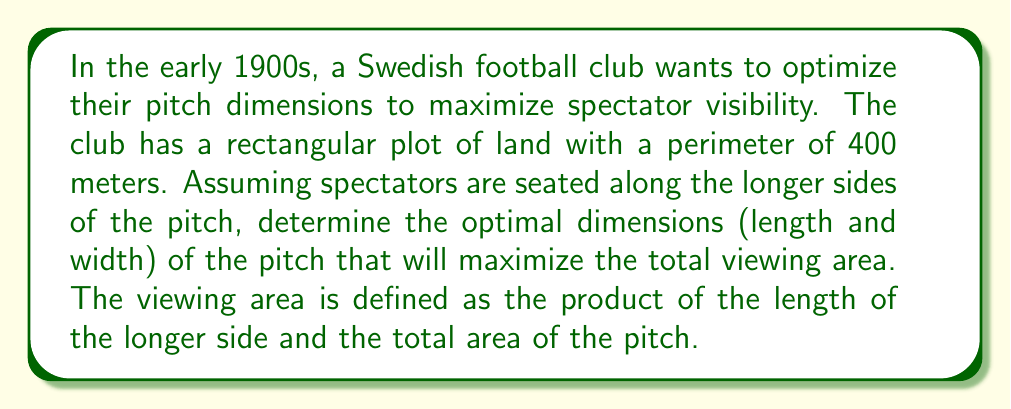Teach me how to tackle this problem. Let's approach this step-by-step:

1) Let $l$ be the length and $w$ be the width of the pitch.

2) Given that the perimeter is 400 meters, we can write:
   $$2l + 2w = 400$$
   $$l + w = 200$$

3) We can express $w$ in terms of $l$:
   $$w = 200 - l$$

4) The area of the pitch is:
   $$A = l \cdot w = l(200-l) = 200l - l^2$$

5) The viewing area (V) is defined as the product of the length and the total area:
   $$V = l \cdot A = l(200l - l^2) = 200l^2 - l^3$$

6) To find the maximum, we differentiate V with respect to l and set it to zero:
   $$\frac{dV}{dl} = 400l - 3l^2 = 0$$

7) Solving this equation:
   $$l(400 - 3l) = 0$$
   $$l = 0$$ or $$400 - 3l = 0$$
   $$l \approx 133.33$$ meters

8) The second derivative is negative at this point, confirming it's a maximum.

9) We can now calculate the width:
   $$w = 200 - 133.33 \approx 66.67$$ meters

[asy]
size(200);
draw((0,0)--(133.33,0)--(133.33,66.67)--(0,66.67)--cycle);
label("133.33 m", (66.67,0), S);
label("66.67 m", (0,33.33), W);
label("Spectators", (66.67,70), N);
label("Spectators", (66.67,-3), S);
[/asy]
Answer: The optimal dimensions for the football pitch are approximately 133.33 meters in length and 66.67 meters in width. 